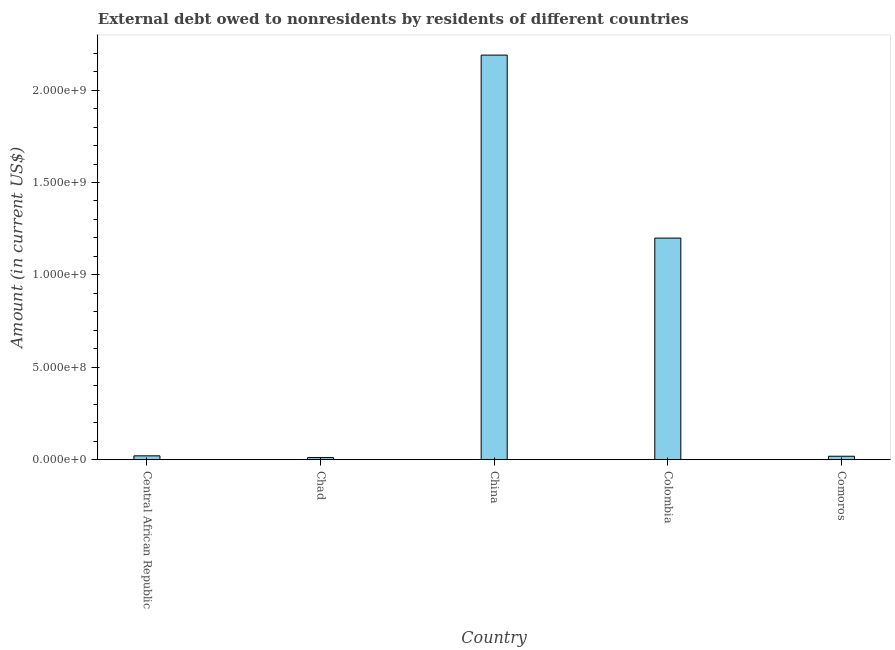Does the graph contain any zero values?
Make the answer very short. No. What is the title of the graph?
Ensure brevity in your answer.  External debt owed to nonresidents by residents of different countries. What is the debt in Comoros?
Your answer should be compact. 1.87e+07. Across all countries, what is the maximum debt?
Ensure brevity in your answer.  2.19e+09. Across all countries, what is the minimum debt?
Provide a short and direct response. 1.15e+07. In which country was the debt maximum?
Keep it short and to the point. China. In which country was the debt minimum?
Your answer should be very brief. Chad. What is the sum of the debt?
Give a very brief answer. 3.44e+09. What is the difference between the debt in Chad and China?
Your answer should be compact. -2.18e+09. What is the average debt per country?
Provide a succinct answer. 6.88e+08. What is the median debt?
Ensure brevity in your answer.  2.09e+07. What is the ratio of the debt in Central African Republic to that in Chad?
Your response must be concise. 1.82. Is the debt in Central African Republic less than that in China?
Give a very brief answer. Yes. Is the difference between the debt in China and Comoros greater than the difference between any two countries?
Offer a terse response. No. What is the difference between the highest and the second highest debt?
Your response must be concise. 9.90e+08. Is the sum of the debt in Chad and China greater than the maximum debt across all countries?
Provide a short and direct response. Yes. What is the difference between the highest and the lowest debt?
Your answer should be very brief. 2.18e+09. How many bars are there?
Keep it short and to the point. 5. What is the Amount (in current US$) in Central African Republic?
Provide a succinct answer. 2.09e+07. What is the Amount (in current US$) of Chad?
Make the answer very short. 1.15e+07. What is the Amount (in current US$) in China?
Provide a short and direct response. 2.19e+09. What is the Amount (in current US$) in Colombia?
Your answer should be very brief. 1.20e+09. What is the Amount (in current US$) in Comoros?
Provide a short and direct response. 1.87e+07. What is the difference between the Amount (in current US$) in Central African Republic and Chad?
Provide a succinct answer. 9.43e+06. What is the difference between the Amount (in current US$) in Central African Republic and China?
Your answer should be very brief. -2.17e+09. What is the difference between the Amount (in current US$) in Central African Republic and Colombia?
Ensure brevity in your answer.  -1.18e+09. What is the difference between the Amount (in current US$) in Central African Republic and Comoros?
Keep it short and to the point. 2.22e+06. What is the difference between the Amount (in current US$) in Chad and China?
Provide a succinct answer. -2.18e+09. What is the difference between the Amount (in current US$) in Chad and Colombia?
Provide a short and direct response. -1.19e+09. What is the difference between the Amount (in current US$) in Chad and Comoros?
Offer a terse response. -7.22e+06. What is the difference between the Amount (in current US$) in China and Colombia?
Make the answer very short. 9.90e+08. What is the difference between the Amount (in current US$) in China and Comoros?
Make the answer very short. 2.17e+09. What is the difference between the Amount (in current US$) in Colombia and Comoros?
Make the answer very short. 1.18e+09. What is the ratio of the Amount (in current US$) in Central African Republic to that in Chad?
Offer a terse response. 1.82. What is the ratio of the Amount (in current US$) in Central African Republic to that in Colombia?
Give a very brief answer. 0.02. What is the ratio of the Amount (in current US$) in Central African Republic to that in Comoros?
Keep it short and to the point. 1.12. What is the ratio of the Amount (in current US$) in Chad to that in China?
Give a very brief answer. 0.01. What is the ratio of the Amount (in current US$) in Chad to that in Colombia?
Ensure brevity in your answer.  0.01. What is the ratio of the Amount (in current US$) in Chad to that in Comoros?
Offer a very short reply. 0.61. What is the ratio of the Amount (in current US$) in China to that in Colombia?
Offer a very short reply. 1.83. What is the ratio of the Amount (in current US$) in China to that in Comoros?
Keep it short and to the point. 117.12. What is the ratio of the Amount (in current US$) in Colombia to that in Comoros?
Give a very brief answer. 64.15. 